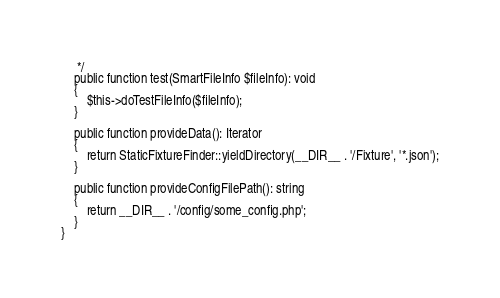<code> <loc_0><loc_0><loc_500><loc_500><_PHP_>     */
    public function test(SmartFileInfo $fileInfo): void
    {
        $this->doTestFileInfo($fileInfo);
    }

    public function provideData(): Iterator
    {
        return StaticFixtureFinder::yieldDirectory(__DIR__ . '/Fixture', '*.json');
    }

    public function provideConfigFilePath(): string
    {
        return __DIR__ . '/config/some_config.php';
    }
}
</code> 